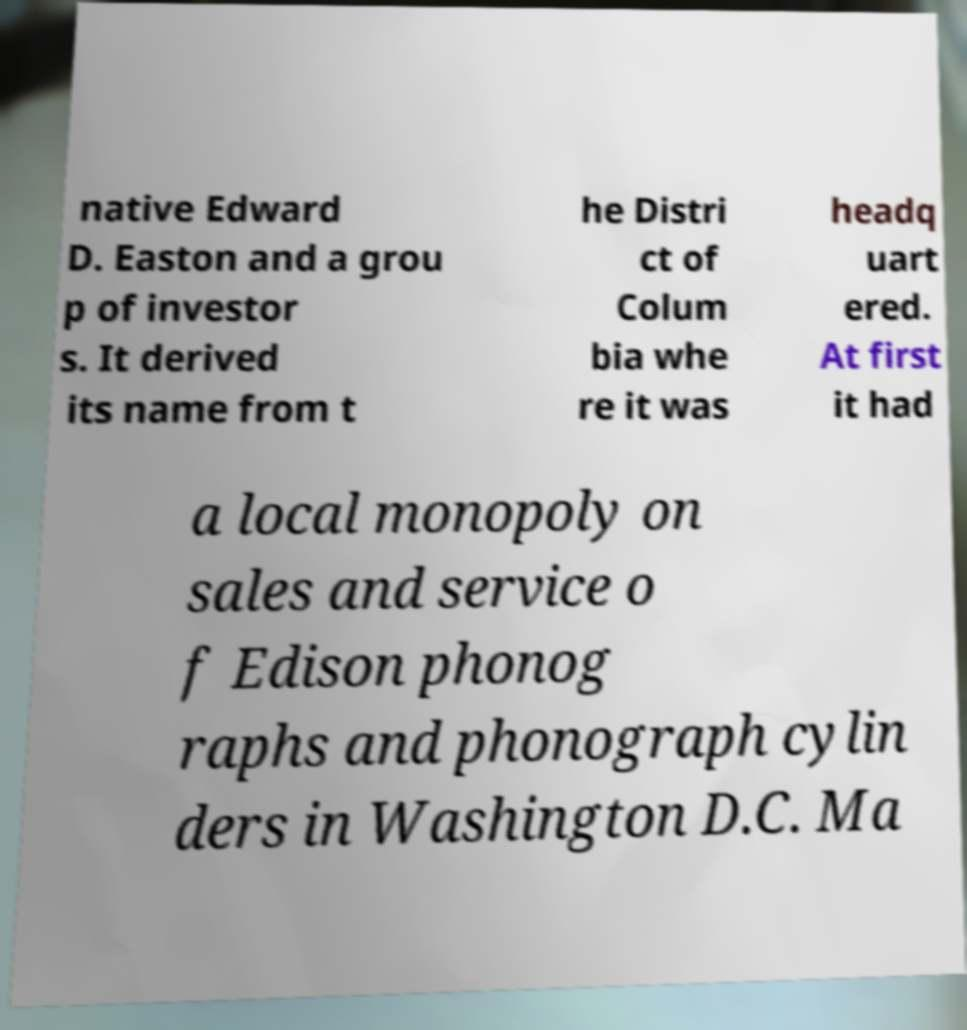Please read and relay the text visible in this image. What does it say? native Edward D. Easton and a grou p of investor s. It derived its name from t he Distri ct of Colum bia whe re it was headq uart ered. At first it had a local monopoly on sales and service o f Edison phonog raphs and phonograph cylin ders in Washington D.C. Ma 